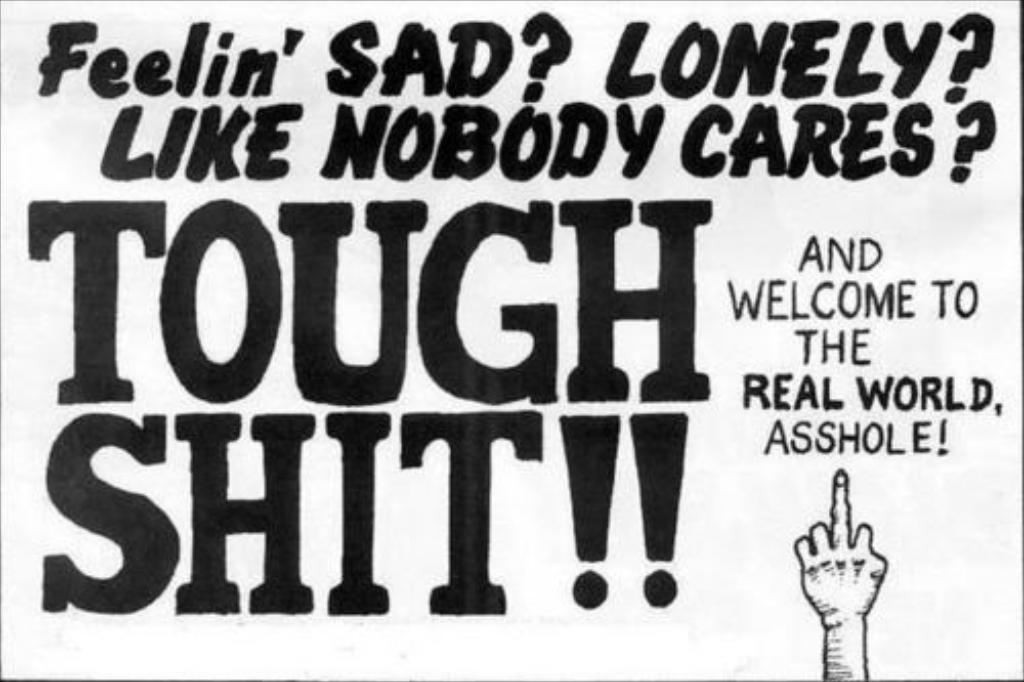What can be found in the image besides the hand? There is some text in the image. Where is the hand located in the image? The hand is at the bottom right side of the image. What type of education is being discussed in the image? There is no discussion of education in the image; it only contains text and a hand. How does the prose in the image capture the reader's attention? There is no prose present in the image, only text. 